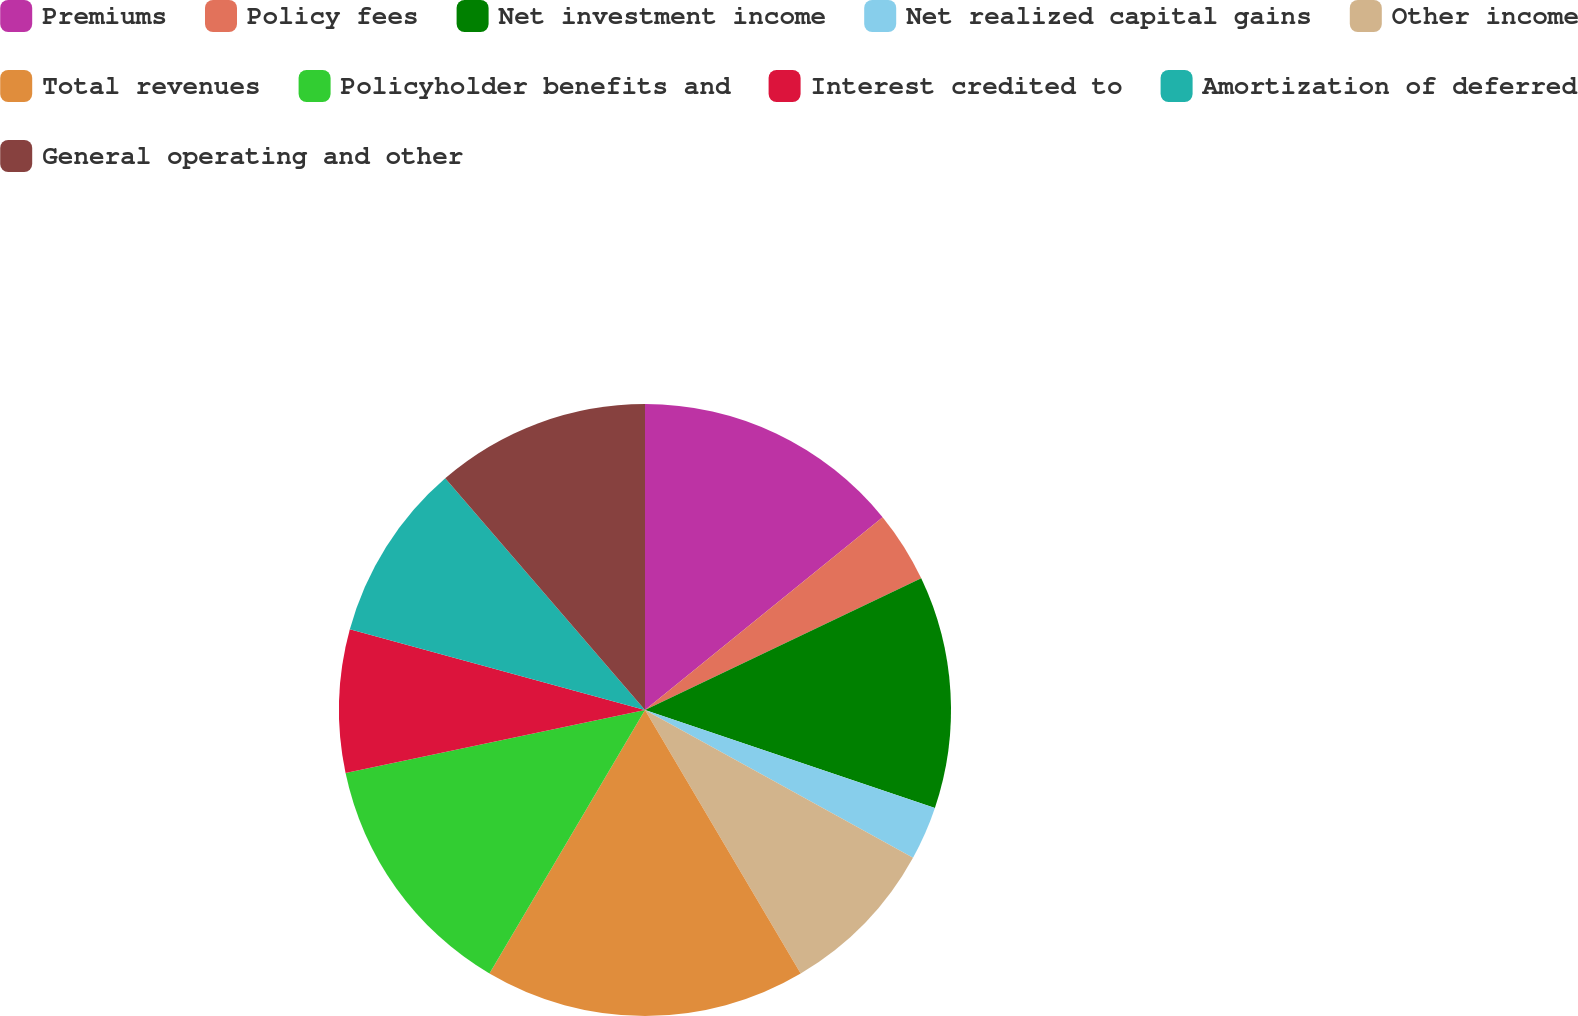<chart> <loc_0><loc_0><loc_500><loc_500><pie_chart><fcel>Premiums<fcel>Policy fees<fcel>Net investment income<fcel>Net realized capital gains<fcel>Other income<fcel>Total revenues<fcel>Policyholder benefits and<fcel>Interest credited to<fcel>Amortization of deferred<fcel>General operating and other<nl><fcel>14.15%<fcel>3.77%<fcel>12.26%<fcel>2.83%<fcel>8.49%<fcel>16.98%<fcel>13.21%<fcel>7.55%<fcel>9.43%<fcel>11.32%<nl></chart> 